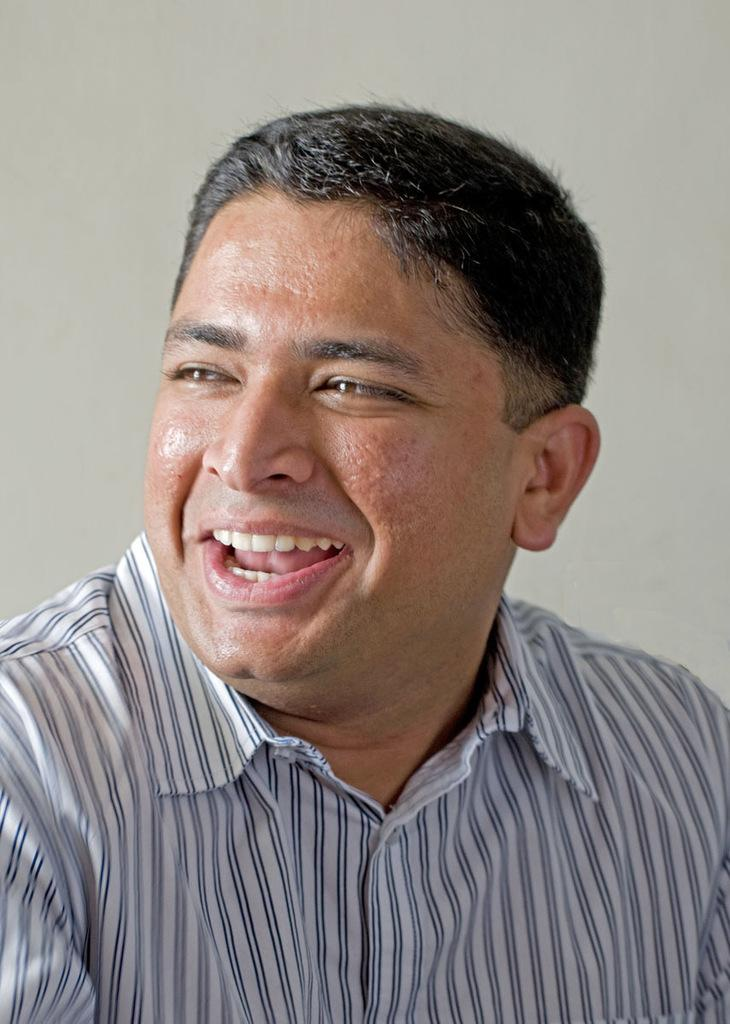What is present in the image? There is a person in the image. What is the person doing in the image? The person is smiling. What can be seen in the background of the image? There is a wall in the background of the image. What type of government is depicted in the image? There is no depiction of a government in the image; it features a person smiling in front of a wall. What nut is being used to open the door in the image? There is no door or nut present in the image. 